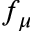Convert formula to latex. <formula><loc_0><loc_0><loc_500><loc_500>f _ { \mu }</formula> 